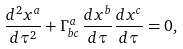Convert formula to latex. <formula><loc_0><loc_0><loc_500><loc_500>\frac { d ^ { 2 } x ^ { a } } { d \tau ^ { 2 } } + \Gamma ^ { a } _ { b c } \, \frac { d x ^ { b } } { d \tau } \frac { d x ^ { c } } { d \tau } = 0 ,</formula> 